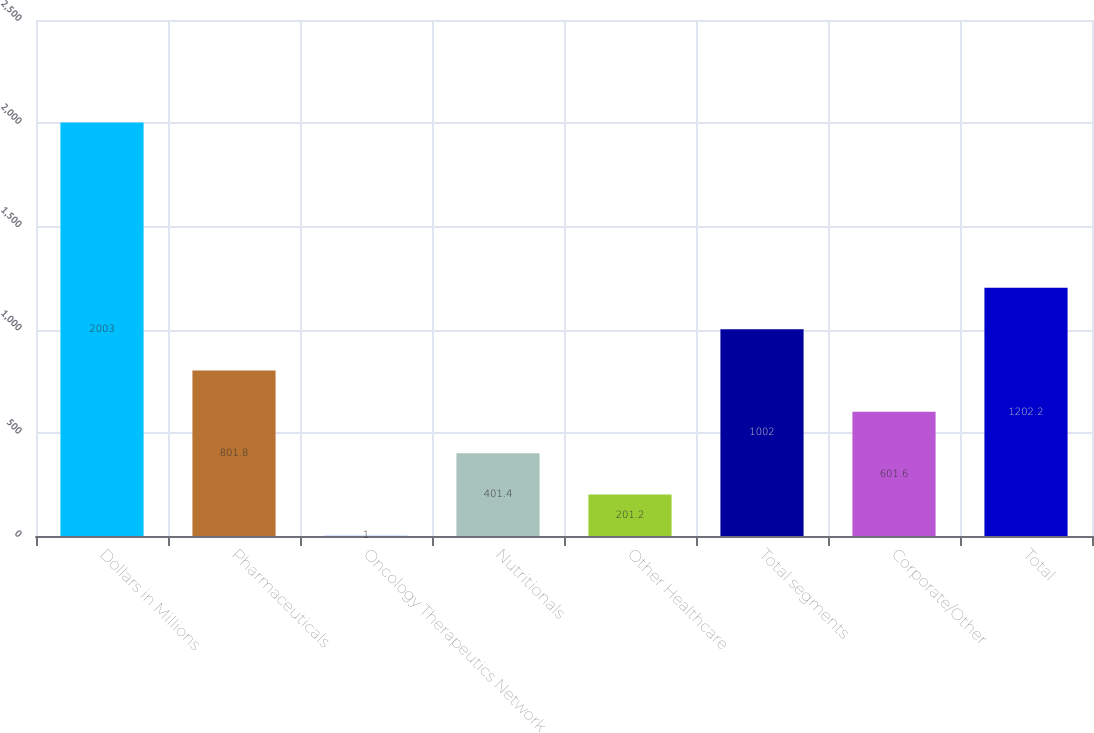Convert chart. <chart><loc_0><loc_0><loc_500><loc_500><bar_chart><fcel>Dollars in Millions<fcel>Pharmaceuticals<fcel>Oncology Therapeutics Network<fcel>Nutritionals<fcel>Other Healthcare<fcel>Total segments<fcel>Corporate/Other<fcel>Total<nl><fcel>2003<fcel>801.8<fcel>1<fcel>401.4<fcel>201.2<fcel>1002<fcel>601.6<fcel>1202.2<nl></chart> 